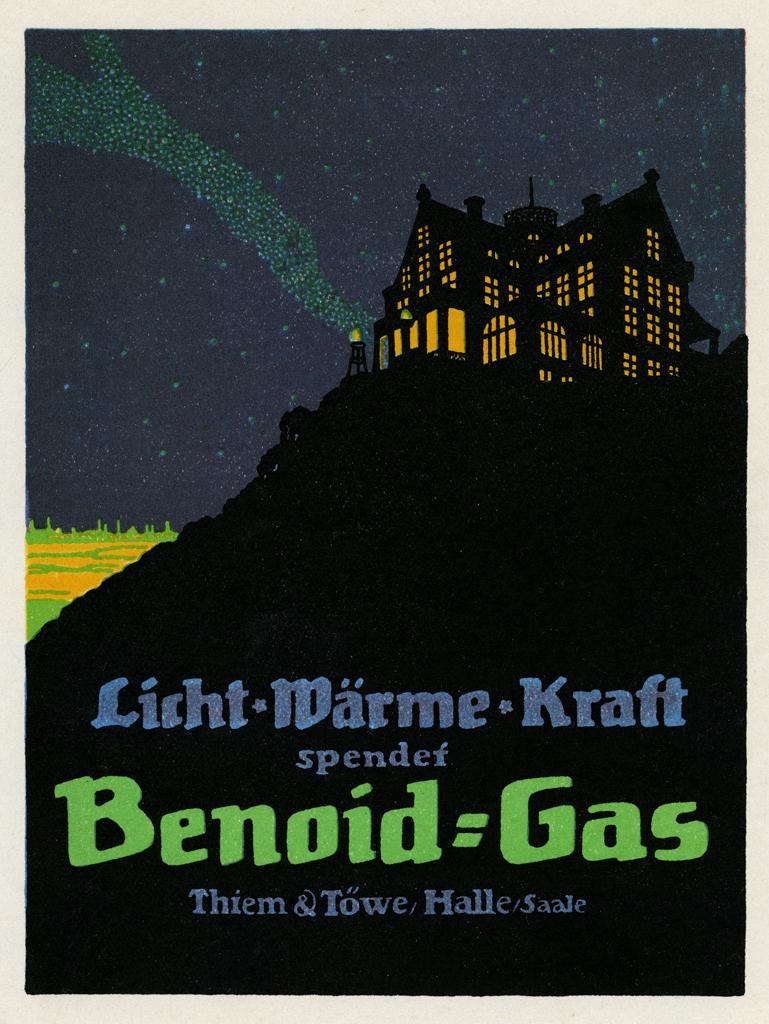Who wrote this book?
Your answer should be very brief. Thiem & towe hallesaale. 